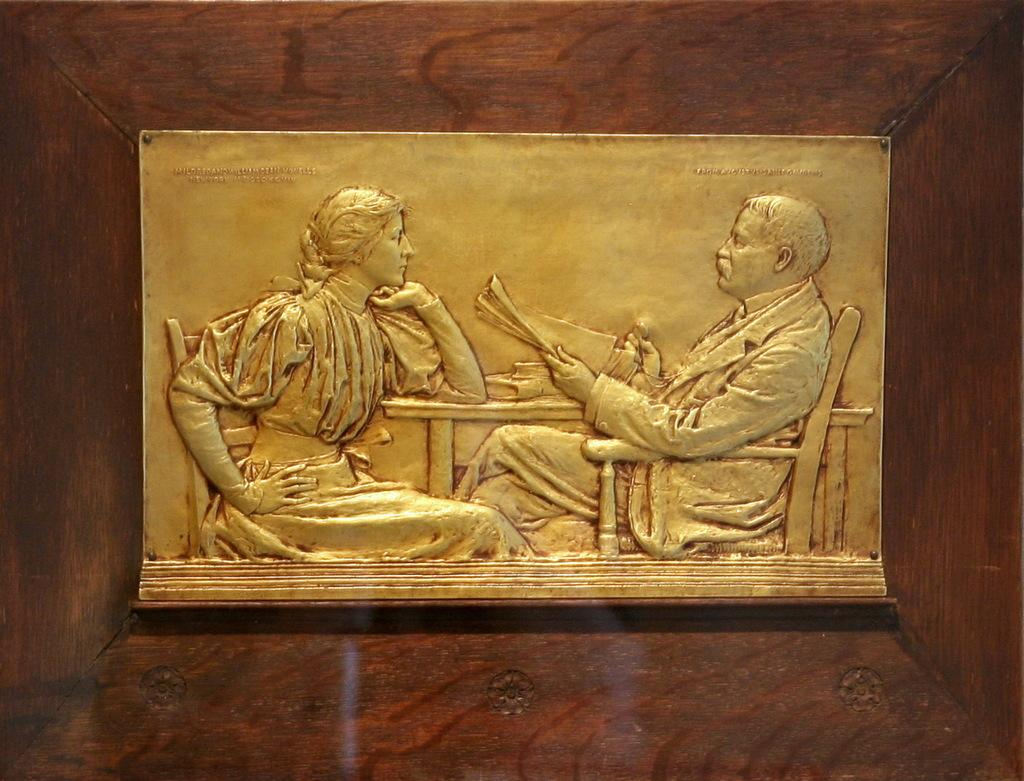What is depicted in the carving in the image? There is a carving of a man and a woman in the image. What are the man and woman doing in the carving? The man and woman are sitting in chairs in the carving. Where are the chairs located in relation to the table? The chairs are in front of a table in the carving. What material is the carving on? The carving is on a metal plate. Where is the metal plate with the carving located? The metal plate with the carving is on the wall. Can you see any geese swimming in the lake in the image? There is no lake or geese present in the image; it features a carving of a man and a woman on a metal plate on the wall. 